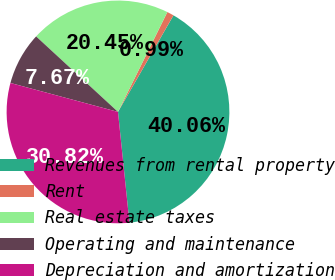Convert chart. <chart><loc_0><loc_0><loc_500><loc_500><pie_chart><fcel>Revenues from rental property<fcel>Rent<fcel>Real estate taxes<fcel>Operating and maintenance<fcel>Depreciation and amortization<nl><fcel>40.06%<fcel>0.99%<fcel>20.45%<fcel>7.67%<fcel>30.82%<nl></chart> 